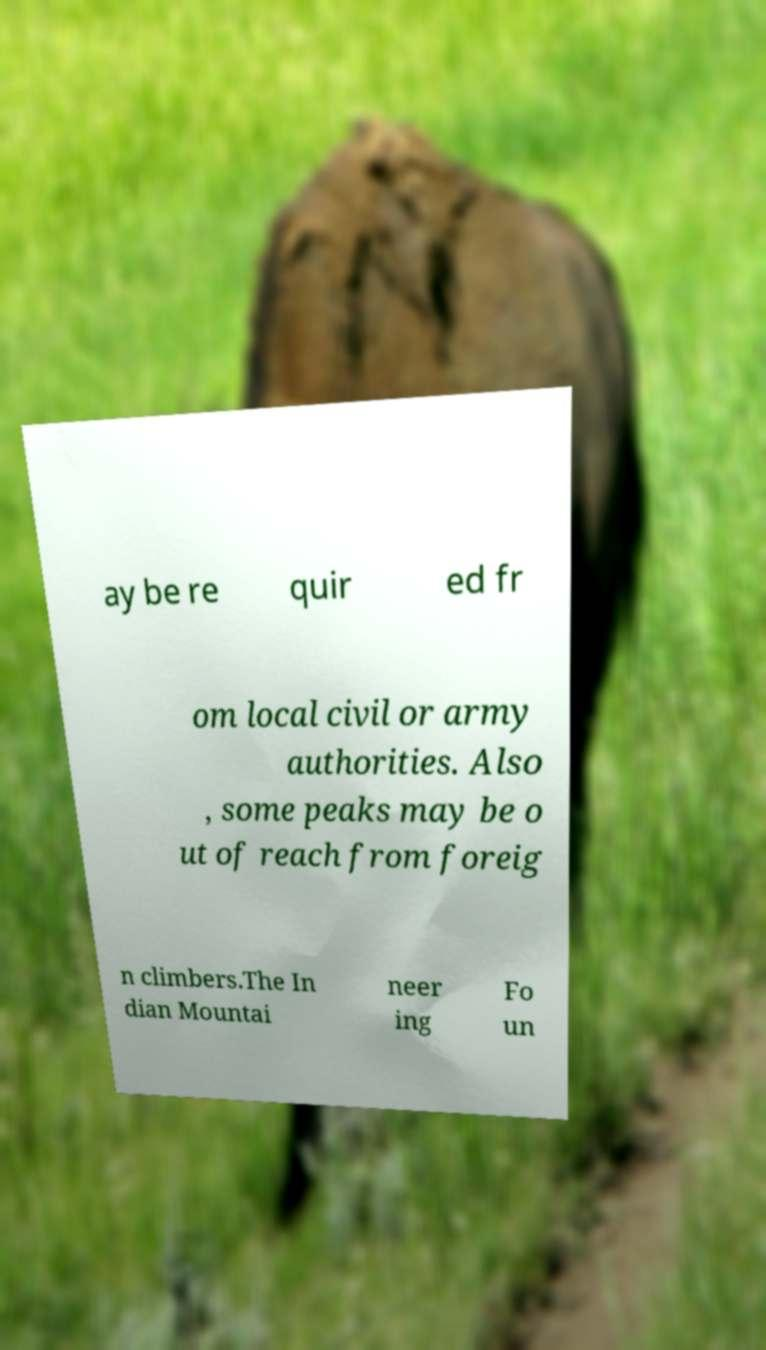Can you accurately transcribe the text from the provided image for me? ay be re quir ed fr om local civil or army authorities. Also , some peaks may be o ut of reach from foreig n climbers.The In dian Mountai neer ing Fo un 